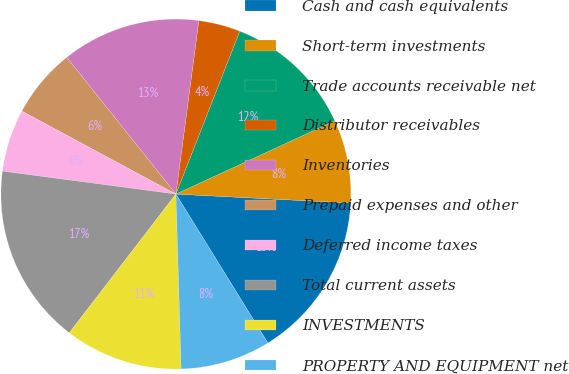Convert chart. <chart><loc_0><loc_0><loc_500><loc_500><pie_chart><fcel>Cash and cash equivalents<fcel>Short-term investments<fcel>Trade accounts receivable net<fcel>Distributor receivables<fcel>Inventories<fcel>Prepaid expenses and other<fcel>Deferred income taxes<fcel>Total current assets<fcel>INVESTMENTS<fcel>PROPERTY AND EQUIPMENT net<nl><fcel>15.38%<fcel>7.69%<fcel>12.18%<fcel>3.85%<fcel>12.82%<fcel>6.41%<fcel>5.77%<fcel>16.67%<fcel>10.9%<fcel>8.33%<nl></chart> 